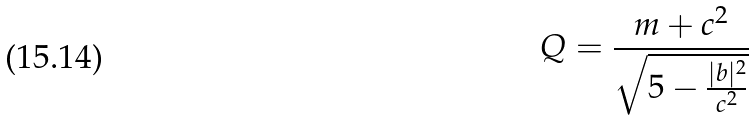Convert formula to latex. <formula><loc_0><loc_0><loc_500><loc_500>Q = \frac { m + c ^ { 2 } } { \sqrt { 5 - \frac { | b | ^ { 2 } } { c ^ { 2 } } } }</formula> 